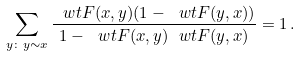<formula> <loc_0><loc_0><loc_500><loc_500>\sum _ { y \colon y \sim x } \frac { \ w t F ( x , y ) ( 1 - \ w t F ( y , x ) ) } { 1 - \ w t F ( x , y ) \ w t F ( y , x ) } = 1 \, .</formula> 